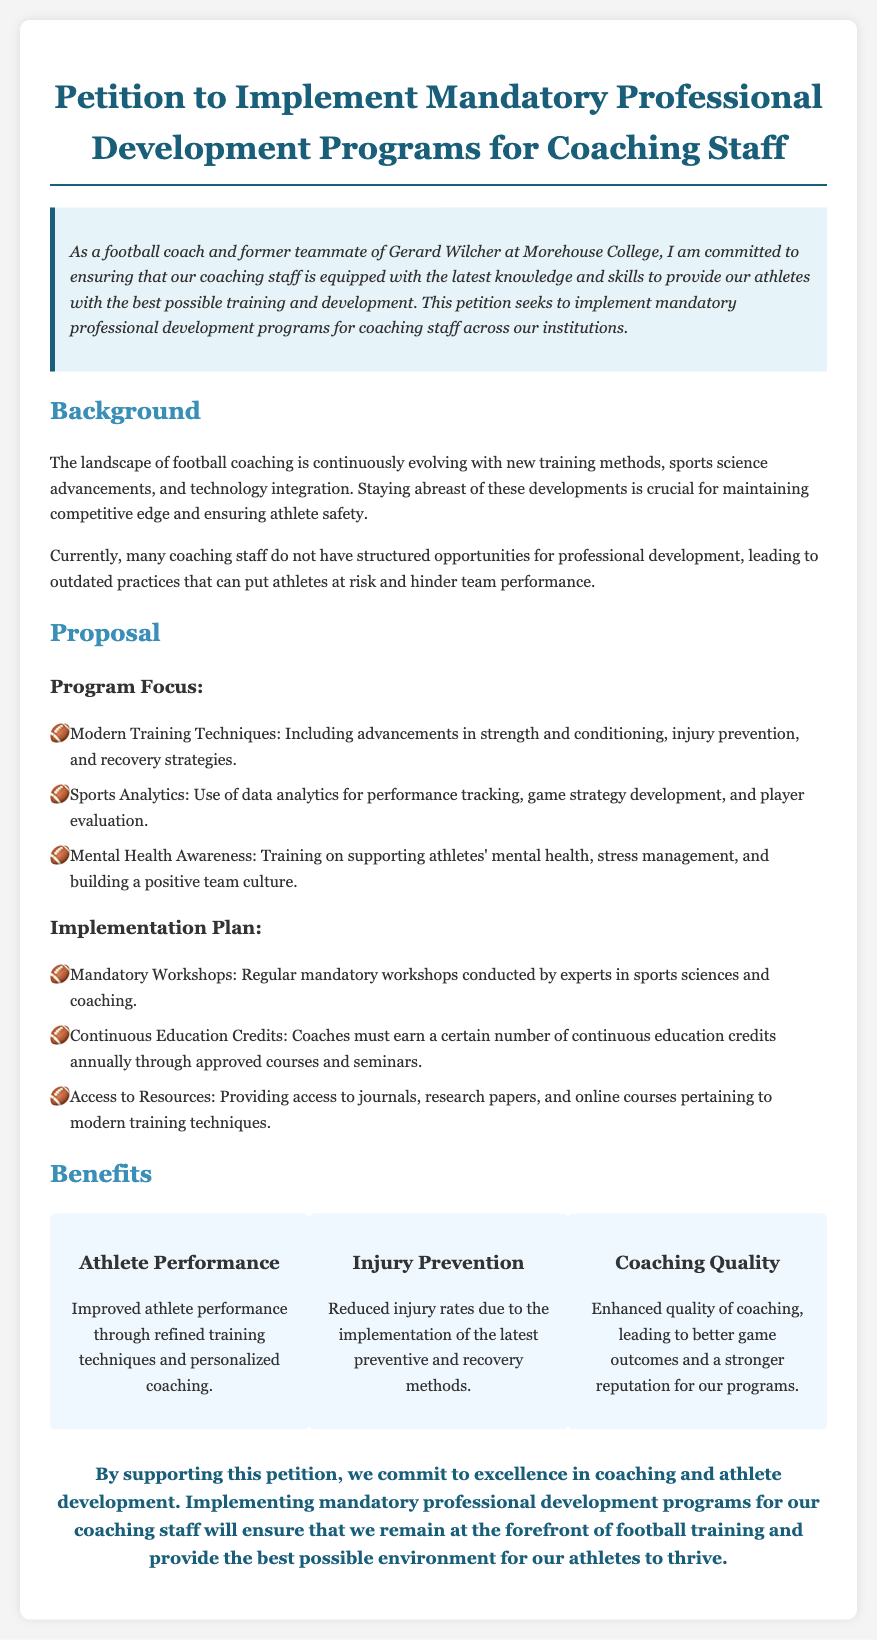What is the title of the petition? The title of the petition is stated at the beginning of the document.
Answer: Petition to Implement Mandatory Professional Development Programs for Coaching Staff Who is the author of the petition? The author introduces themselves as a football coach and former teammate of Gerard Wilcher at Morehouse College.
Answer: A football coach and former teammate of Gerard Wilcher What is the first focus area of the proposed program? The document lists the first focus area of the proposed program under "Program Focus."
Answer: Modern Training Techniques What are the implementation methods proposed? The implementation methods are outlined in the "Implementation Plan" section.
Answer: Mandatory Workshops What is one benefit mentioned regarding athlete performance? The benefits section includes statements about improved athlete performance.
Answer: Improved athlete performance How often do coaches need to earn continuous education credits? This requirement is mentioned in the Implementation Plan section of the petition.
Answer: Annually What is a key aspect of training mentioned that supports athlete mental health? The document lists mental health awareness as part of the program focus.
Answer: Mental Health Awareness What is the conclusion of the petition? The conclusion summarizes the intent and benefits of supporting the petition.
Answer: Commit to excellence in coaching and athlete development Which sport is primarily discussed in this petition? The entire document is centered around a specific sport mentioned prominently throughout.
Answer: Football 